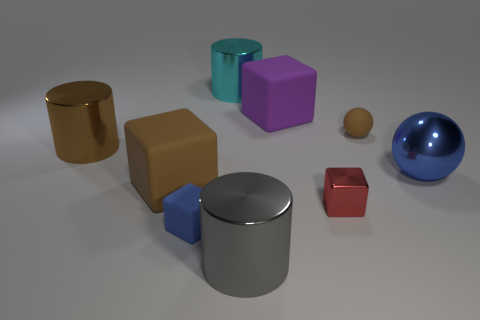Do the colors of the objects follow any particular pattern? There doesn't seem to be a specific pattern to the color arrangement of the objects. They vary individually and include gold, purple, blue, red, tan, and the neutral color of silver. Which object appears to be the smallest and what is its color? The smallest object seems to be the tiny brown sphere, and its color is a muted brown or tan, which is distinct from the more vibrant and larger objects in the scene. 